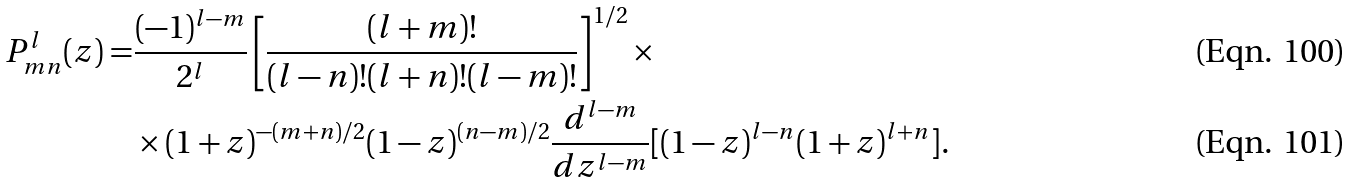<formula> <loc_0><loc_0><loc_500><loc_500>P _ { m n } ^ { l } ( z ) = & \frac { ( - 1 ) ^ { l - m } } { 2 ^ { l } } \left [ \frac { ( l + m ) ! } { ( l - n ) ! ( l + n ) ! ( l - m ) ! } \right ] ^ { 1 / 2 } \times \\ & \times ( 1 + z ) ^ { - ( m + n ) / 2 } ( 1 - z ) ^ { ( n - m ) / 2 } \frac { d ^ { l - m } } { d z ^ { l - m } } [ ( 1 - z ) ^ { l - n } ( 1 + z ) ^ { l + n } ] .</formula> 